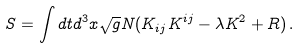<formula> <loc_0><loc_0><loc_500><loc_500>S = \int d t d ^ { 3 } x \sqrt { g } N ( K _ { i j } K ^ { i j } - \lambda K ^ { 2 } + R ) \, .</formula> 